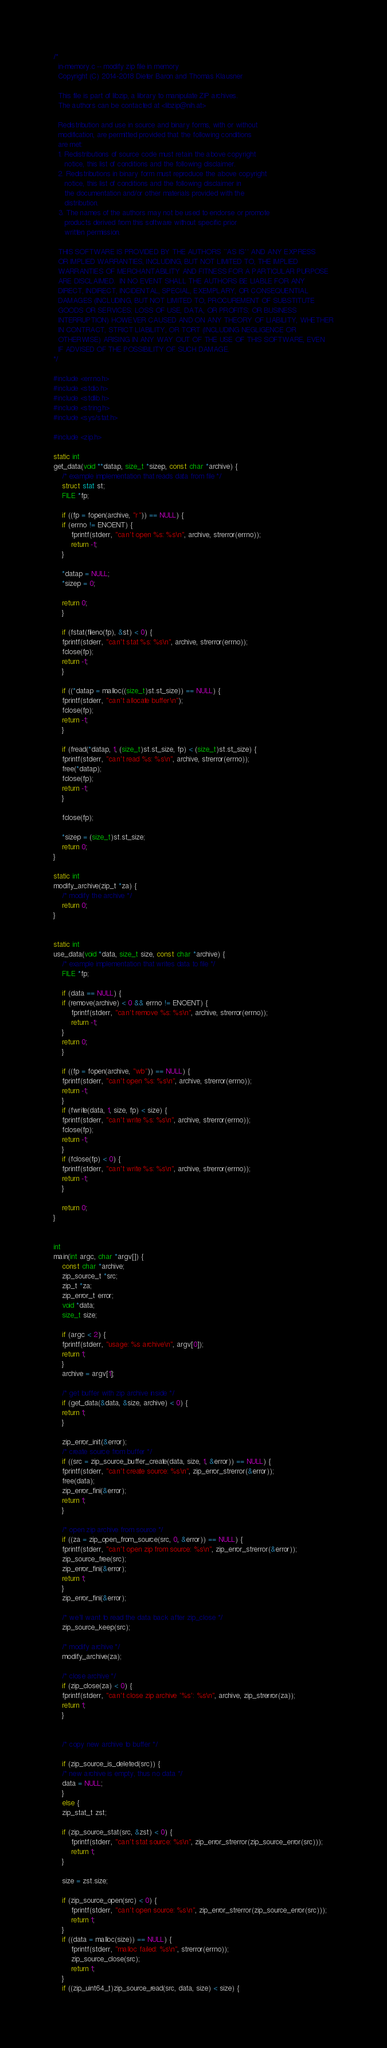Convert code to text. <code><loc_0><loc_0><loc_500><loc_500><_C++_>/*
  in-memory.c -- modify zip file in memory
  Copyright (C) 2014-2018 Dieter Baron and Thomas Klausner

  This file is part of libzip, a library to manipulate ZIP archives.
  The authors can be contacted at <libzip@nih.at>

  Redistribution and use in source and binary forms, with or without
  modification, are permitted provided that the following conditions
  are met:
  1. Redistributions of source code must retain the above copyright
     notice, this list of conditions and the following disclaimer.
  2. Redistributions in binary form must reproduce the above copyright
     notice, this list of conditions and the following disclaimer in
     the documentation and/or other materials provided with the
     distribution.
  3. The names of the authors may not be used to endorse or promote
     products derived from this software without specific prior
     written permission.

  THIS SOFTWARE IS PROVIDED BY THE AUTHORS ``AS IS'' AND ANY EXPRESS
  OR IMPLIED WARRANTIES, INCLUDING, BUT NOT LIMITED TO, THE IMPLIED
  WARRANTIES OF MERCHANTABILITY AND FITNESS FOR A PARTICULAR PURPOSE
  ARE DISCLAIMED.  IN NO EVENT SHALL THE AUTHORS BE LIABLE FOR ANY
  DIRECT, INDIRECT, INCIDENTAL, SPECIAL, EXEMPLARY, OR CONSEQUENTIAL
  DAMAGES (INCLUDING, BUT NOT LIMITED TO, PROCUREMENT OF SUBSTITUTE
  GOODS OR SERVICES; LOSS OF USE, DATA, OR PROFITS; OR BUSINESS
  INTERRUPTION) HOWEVER CAUSED AND ON ANY THEORY OF LIABILITY, WHETHER
  IN CONTRACT, STRICT LIABILITY, OR TORT (INCLUDING NEGLIGENCE OR
  OTHERWISE) ARISING IN ANY WAY OUT OF THE USE OF THIS SOFTWARE, EVEN
  IF ADVISED OF THE POSSIBILITY OF SUCH DAMAGE.
*/

#include <errno.h>
#include <stdio.h>
#include <stdlib.h>
#include <string.h>
#include <sys/stat.h>

#include <zip.h>

static int
get_data(void **datap, size_t *sizep, const char *archive) {
    /* example implementation that reads data from file */
    struct stat st;
    FILE *fp;

    if ((fp = fopen(archive, "r")) == NULL) {
	if (errno != ENOENT) {
	    fprintf(stderr, "can't open %s: %s\n", archive, strerror(errno));
	    return -1;
	}

	*datap = NULL;
	*sizep = 0;

	return 0;
    }

    if (fstat(fileno(fp), &st) < 0) {
	fprintf(stderr, "can't stat %s: %s\n", archive, strerror(errno));
	fclose(fp);
	return -1;
    }

    if ((*datap = malloc((size_t)st.st_size)) == NULL) {
	fprintf(stderr, "can't allocate buffer\n");
	fclose(fp);
	return -1;
    }

    if (fread(*datap, 1, (size_t)st.st_size, fp) < (size_t)st.st_size) {
	fprintf(stderr, "can't read %s: %s\n", archive, strerror(errno));
	free(*datap);
	fclose(fp);
	return -1;
    }

    fclose(fp);

    *sizep = (size_t)st.st_size;
    return 0;
}

static int
modify_archive(zip_t *za) {
    /* modify the archive */
    return 0;
}


static int
use_data(void *data, size_t size, const char *archive) {
    /* example implementation that writes data to file */
    FILE *fp;

    if (data == NULL) {
	if (remove(archive) < 0 && errno != ENOENT) {
	    fprintf(stderr, "can't remove %s: %s\n", archive, strerror(errno));
	    return -1;
	}
	return 0;
    }

    if ((fp = fopen(archive, "wb")) == NULL) {
	fprintf(stderr, "can't open %s: %s\n", archive, strerror(errno));
	return -1;
    }
    if (fwrite(data, 1, size, fp) < size) {
	fprintf(stderr, "can't write %s: %s\n", archive, strerror(errno));
	fclose(fp);
	return -1;
    }
    if (fclose(fp) < 0) {
	fprintf(stderr, "can't write %s: %s\n", archive, strerror(errno));
	return -1;
    }

    return 0;
}


int
main(int argc, char *argv[]) {
    const char *archive;
    zip_source_t *src;
    zip_t *za;
    zip_error_t error;
    void *data;
    size_t size;

    if (argc < 2) {
	fprintf(stderr, "usage: %s archive\n", argv[0]);
	return 1;
    }
    archive = argv[1];

    /* get buffer with zip archive inside */
    if (get_data(&data, &size, archive) < 0) {
	return 1;
    }

    zip_error_init(&error);
    /* create source from buffer */
    if ((src = zip_source_buffer_create(data, size, 1, &error)) == NULL) {
	fprintf(stderr, "can't create source: %s\n", zip_error_strerror(&error));
	free(data);
	zip_error_fini(&error);
	return 1;
    }

    /* open zip archive from source */
    if ((za = zip_open_from_source(src, 0, &error)) == NULL) {
	fprintf(stderr, "can't open zip from source: %s\n", zip_error_strerror(&error));
	zip_source_free(src);
	zip_error_fini(&error);
	return 1;
    }
    zip_error_fini(&error);

    /* we'll want to read the data back after zip_close */
    zip_source_keep(src);

    /* modify archive */
    modify_archive(za);

    /* close archive */
    if (zip_close(za) < 0) {
	fprintf(stderr, "can't close zip archive '%s': %s\n", archive, zip_strerror(za));
	return 1;
    }


    /* copy new archive to buffer */

    if (zip_source_is_deleted(src)) {
	/* new archive is empty, thus no data */
	data = NULL;
    }
    else {
	zip_stat_t zst;

	if (zip_source_stat(src, &zst) < 0) {
	    fprintf(stderr, "can't stat source: %s\n", zip_error_strerror(zip_source_error(src)));
	    return 1;
	}

	size = zst.size;

	if (zip_source_open(src) < 0) {
	    fprintf(stderr, "can't open source: %s\n", zip_error_strerror(zip_source_error(src)));
	    return 1;
	}
	if ((data = malloc(size)) == NULL) {
	    fprintf(stderr, "malloc failed: %s\n", strerror(errno));
	    zip_source_close(src);
	    return 1;
	}
	if ((zip_uint64_t)zip_source_read(src, data, size) < size) {</code> 